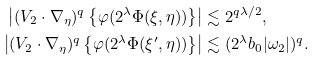<formula> <loc_0><loc_0><loc_500><loc_500>\left | ( V _ { 2 } \cdot \nabla _ { \eta } ) ^ { q } \left \{ \varphi ( 2 ^ { \lambda } \Phi ( \xi , \eta ) ) \right \} \right | & \lesssim 2 ^ { q \lambda / 2 } , \\ \left | ( V _ { 2 } \cdot \nabla _ { \eta } ) ^ { q } \left \{ \varphi ( 2 ^ { \lambda } \Phi ( \xi ^ { \prime } , \eta ) ) \right \} \right | & \lesssim ( 2 ^ { \lambda } b _ { 0 } | \omega _ { 2 } | ) ^ { q } .</formula> 